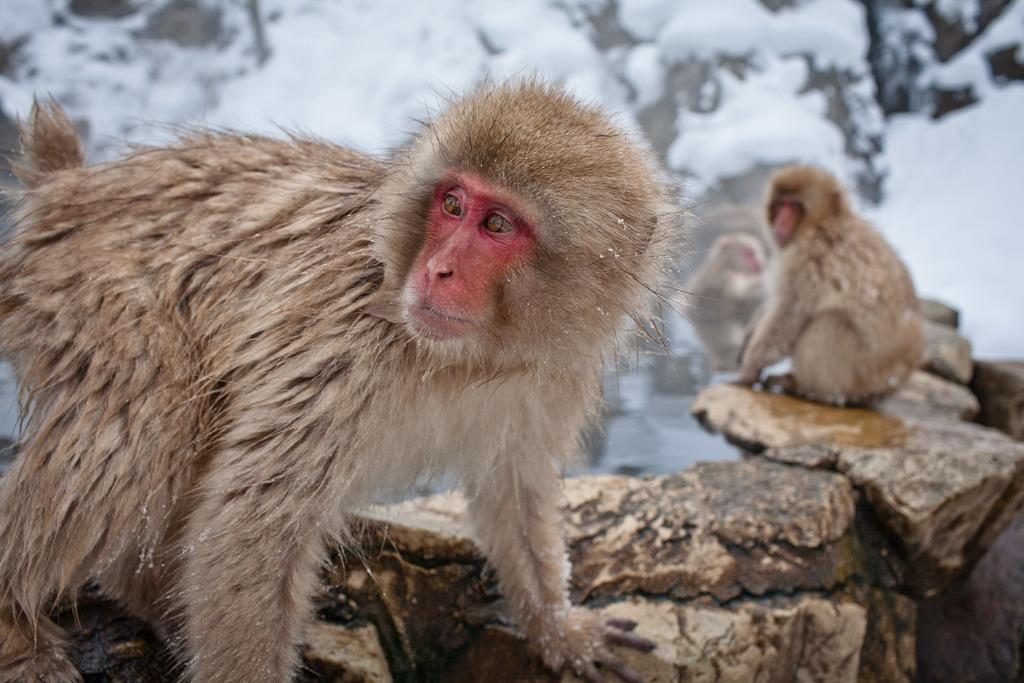What animals are present in the image? There are monkeys in the image. What are the monkeys standing on? The monkeys are standing on rocks. What type of environment is suggested by the presence of snow in the background? The presence of snow in the background suggests a cold environment, possibly a snowy landscape. What type of veil is being worn by the monkeys in the image? There is no veil present in the image; the monkeys are not wearing any clothing or accessories. What religious symbol can be seen in the image? There is no religious symbol present in the image; the image only features monkeys standing on rocks with snow in the background. 